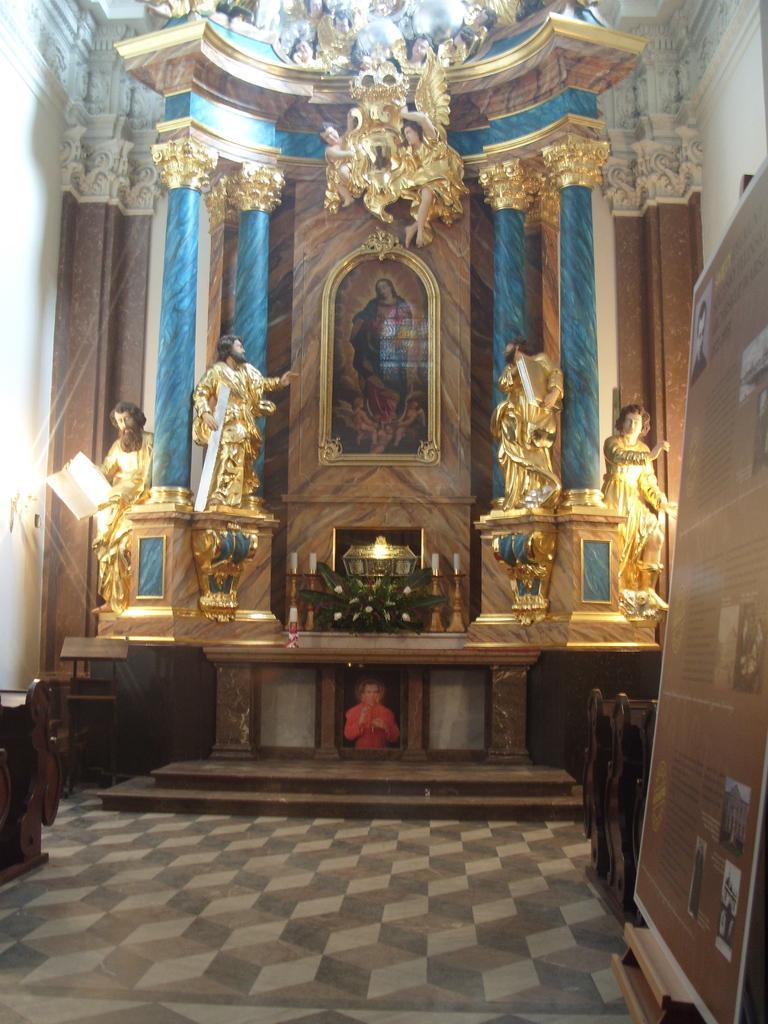How would you summarize this image in a sentence or two? This picture shows a building and we see few statues and a board on the side. 